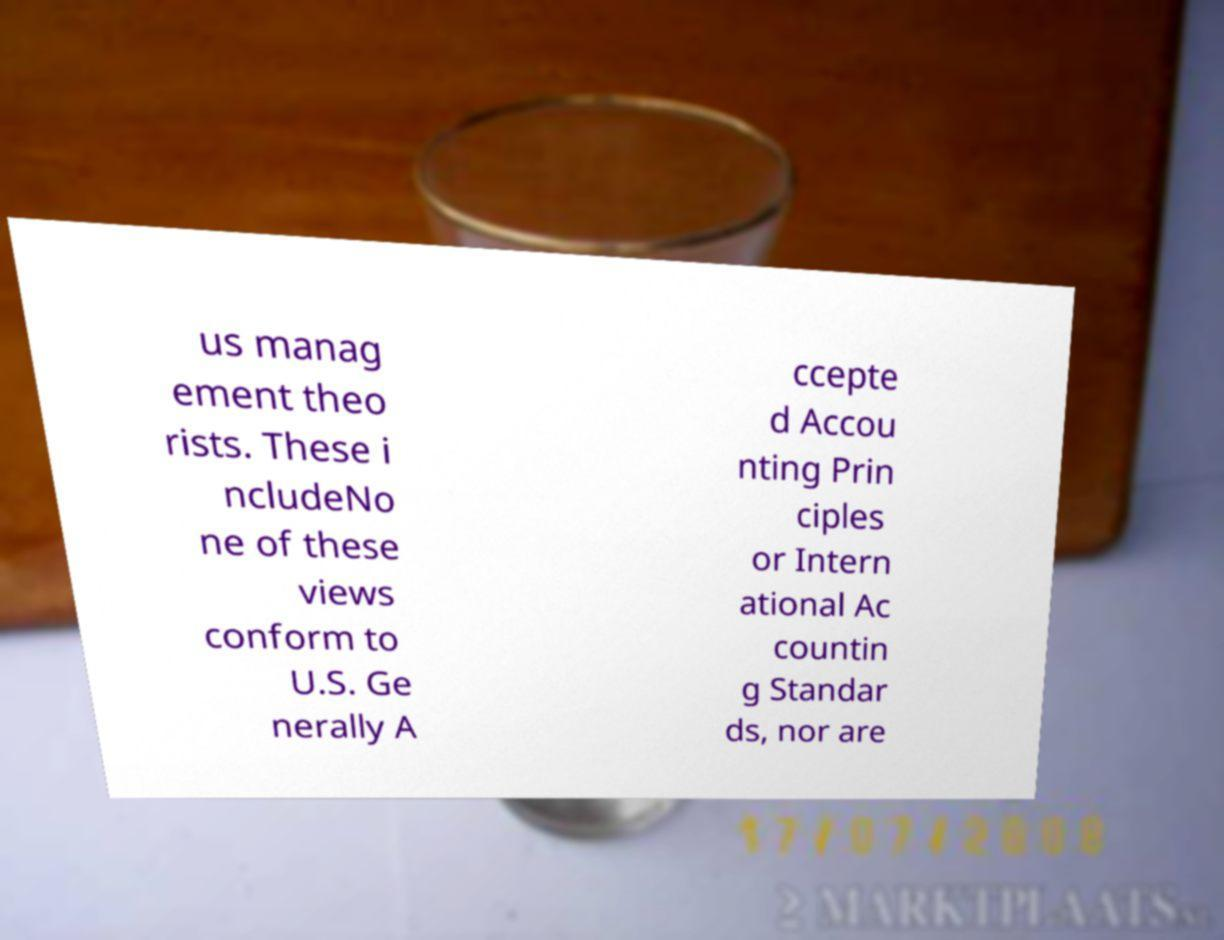There's text embedded in this image that I need extracted. Can you transcribe it verbatim? us manag ement theo rists. These i ncludeNo ne of these views conform to U.S. Ge nerally A ccepte d Accou nting Prin ciples or Intern ational Ac countin g Standar ds, nor are 